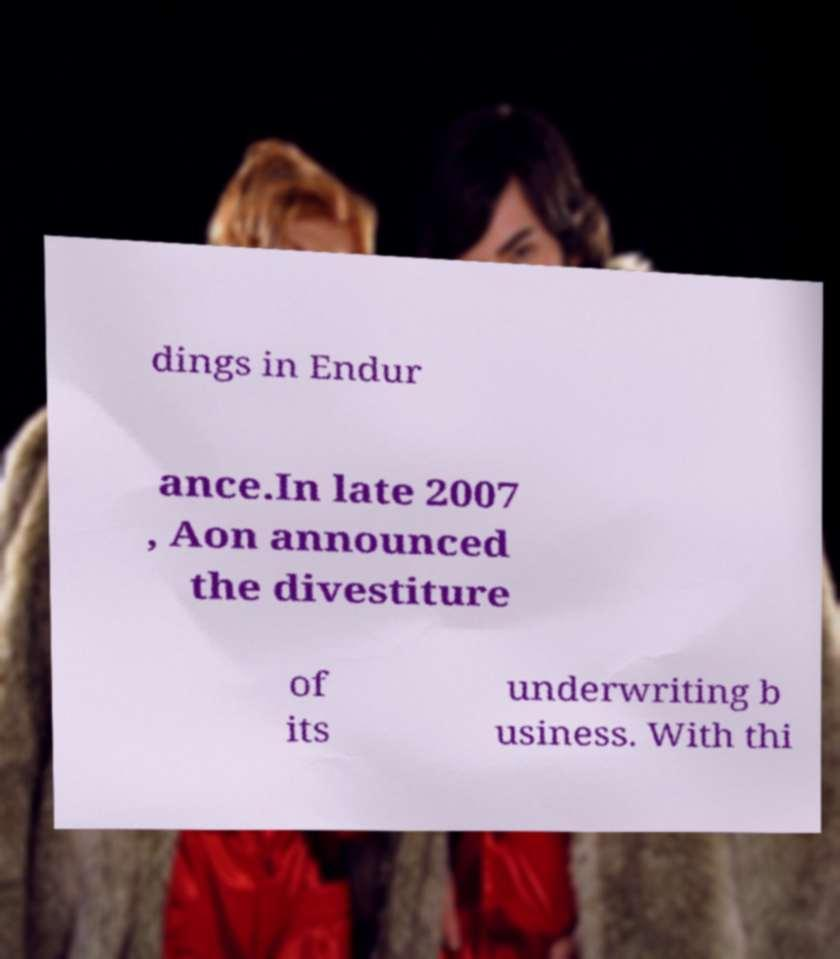I need the written content from this picture converted into text. Can you do that? dings in Endur ance.In late 2007 , Aon announced the divestiture of its underwriting b usiness. With thi 